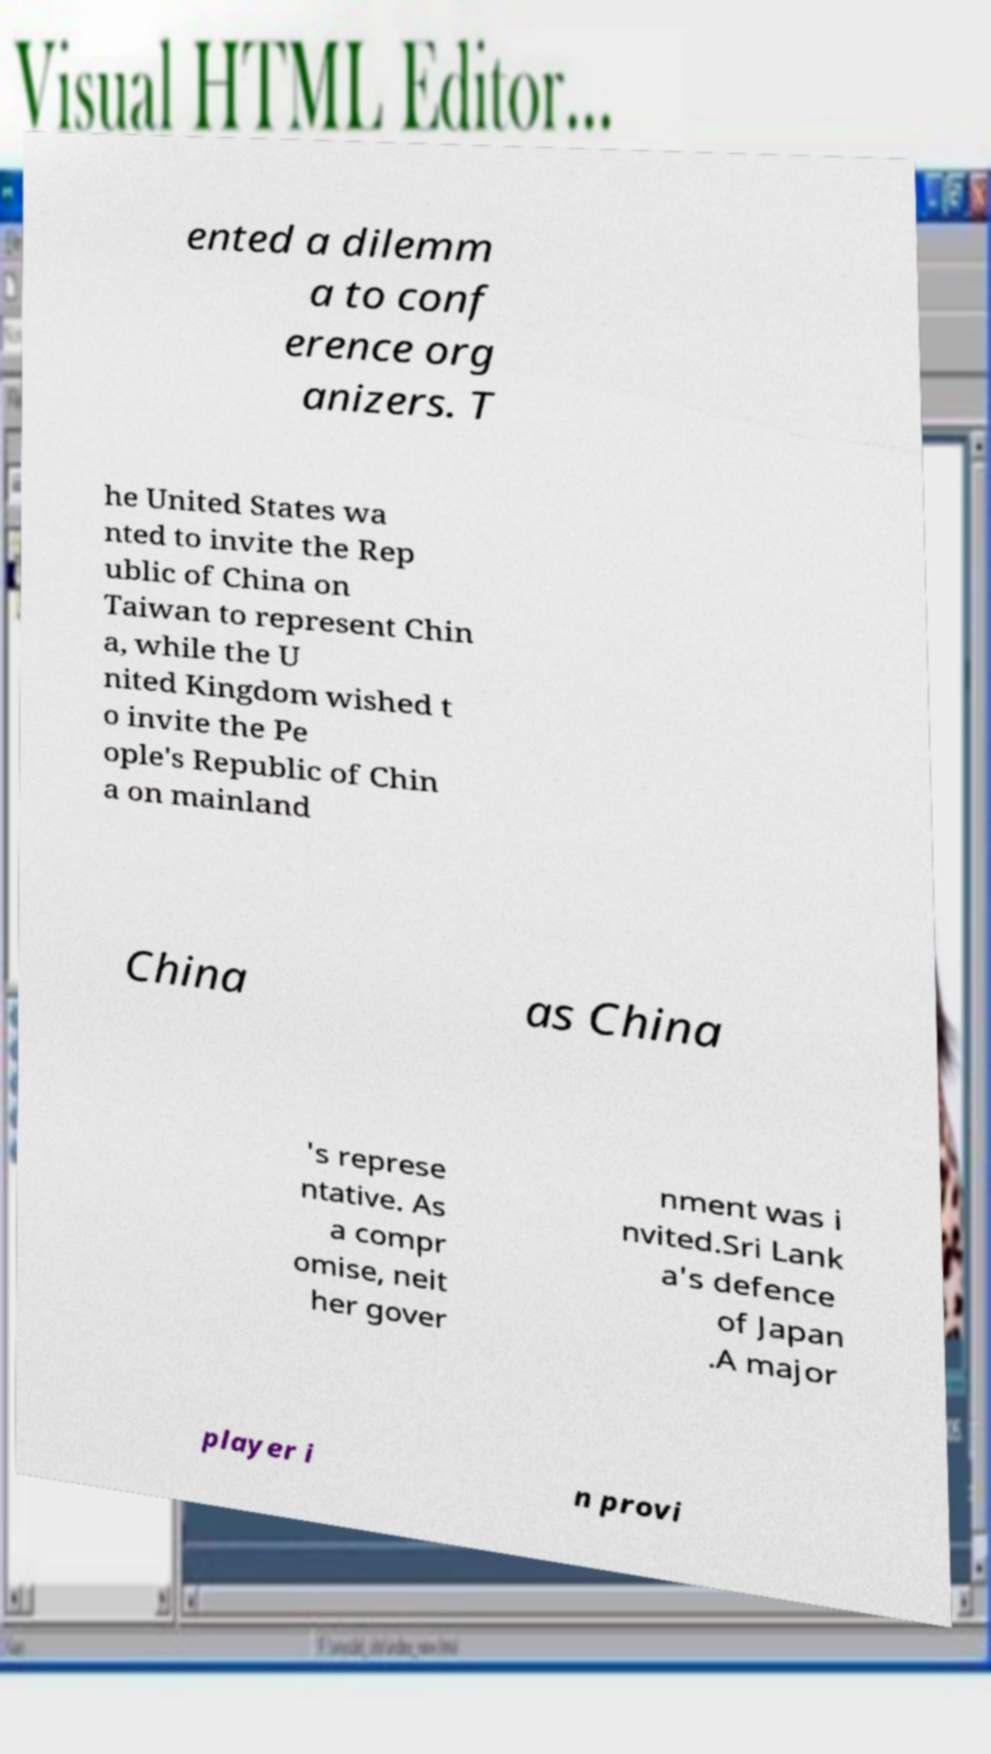Can you read and provide the text displayed in the image?This photo seems to have some interesting text. Can you extract and type it out for me? ented a dilemm a to conf erence org anizers. T he United States wa nted to invite the Rep ublic of China on Taiwan to represent Chin a, while the U nited Kingdom wished t o invite the Pe ople's Republic of Chin a on mainland China as China 's represe ntative. As a compr omise, neit her gover nment was i nvited.Sri Lank a's defence of Japan .A major player i n provi 